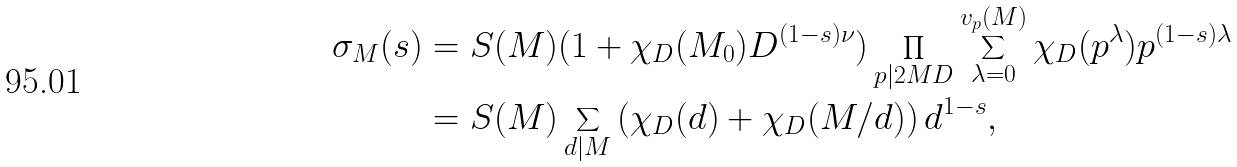<formula> <loc_0><loc_0><loc_500><loc_500>\sigma _ { M } ( s ) & = S ( M ) ( 1 + \chi _ { D } ( M _ { 0 } ) D ^ { ( 1 - s ) \nu } ) \prod _ { p | 2 M D } \sum _ { \lambda = 0 } ^ { v _ { p } ( M ) } \chi _ { D } ( p ^ { \lambda } ) p ^ { ( 1 - s ) \lambda } \\ & = S ( M ) \sum _ { d | M } \left ( \chi _ { D } ( d ) + \chi _ { D } ( M / d ) \right ) d ^ { 1 - s } ,</formula> 